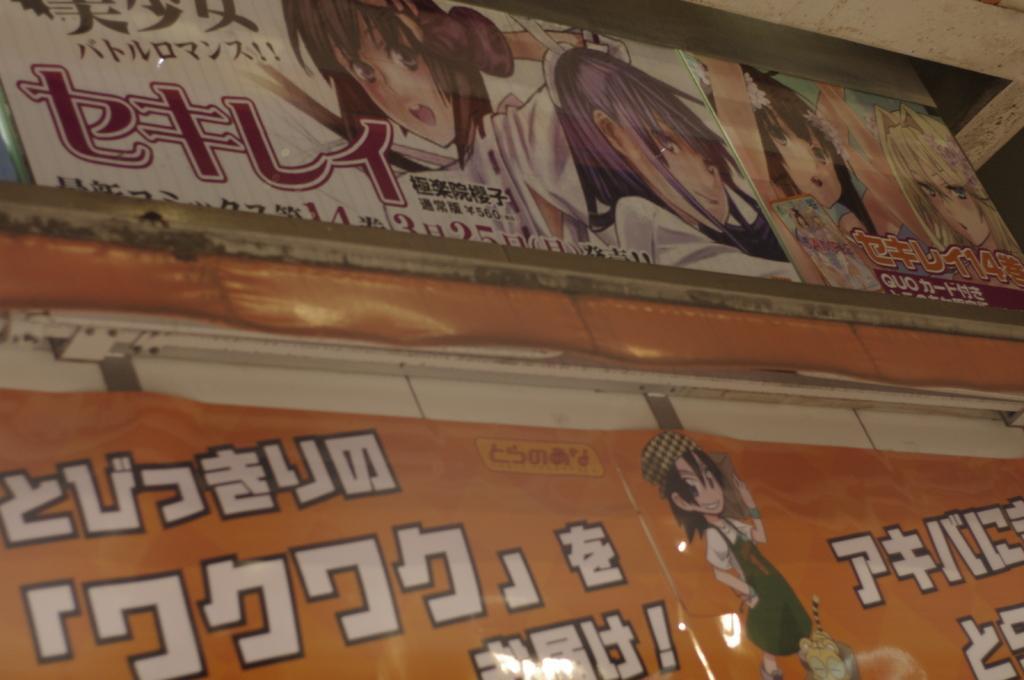Can you describe this image briefly? In this image there are two posters with text and cartoons on the wall. 